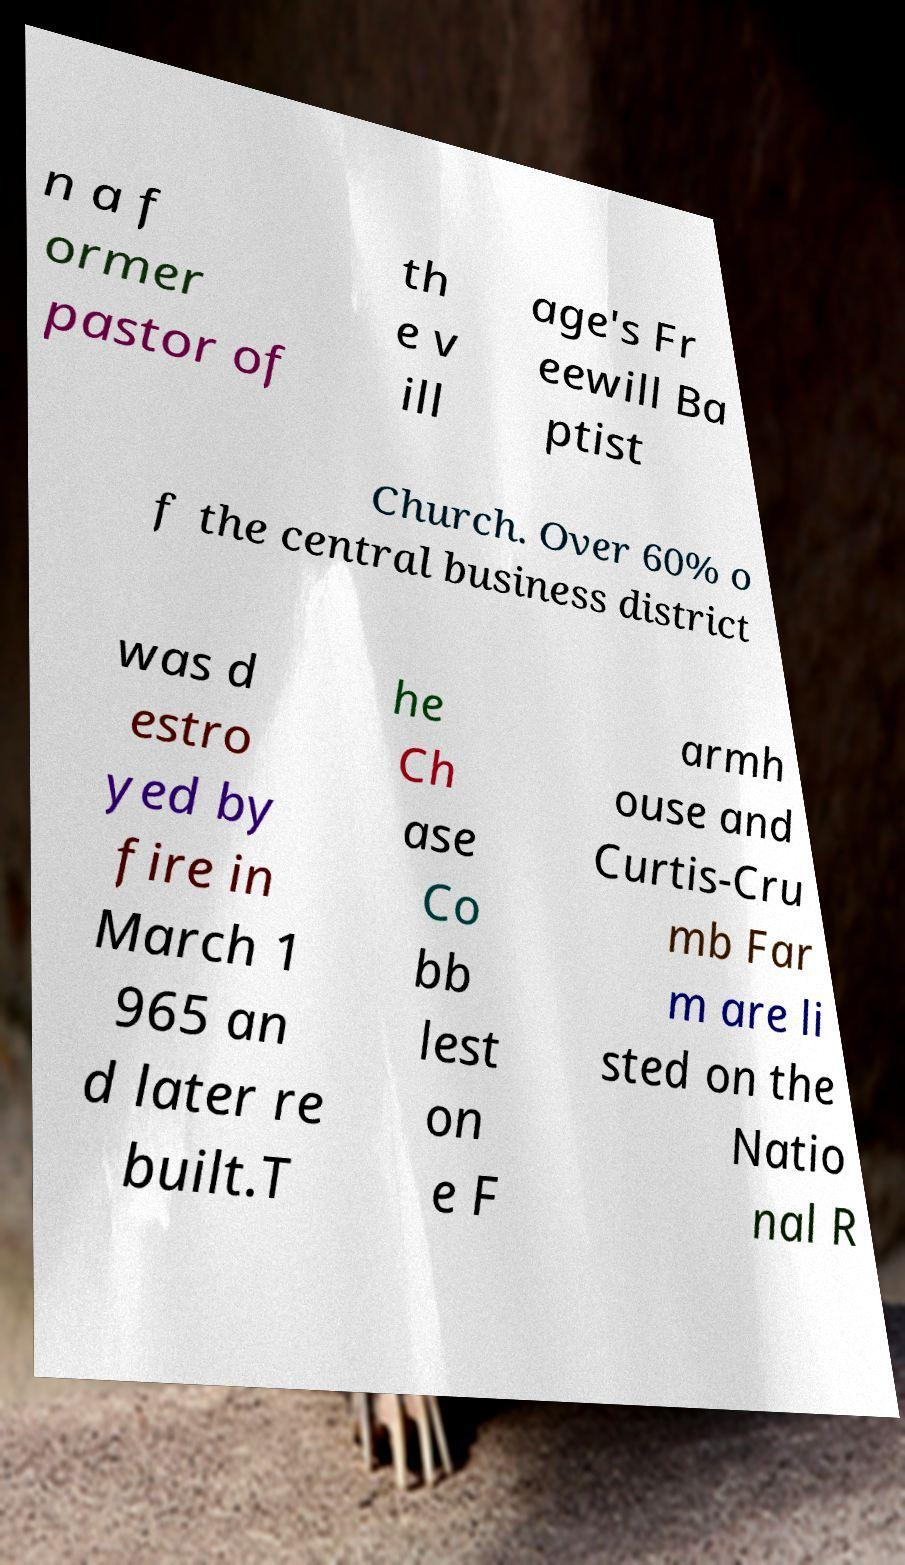What messages or text are displayed in this image? I need them in a readable, typed format. n a f ormer pastor of th e v ill age's Fr eewill Ba ptist Church. Over 60% o f the central business district was d estro yed by fire in March 1 965 an d later re built.T he Ch ase Co bb lest on e F armh ouse and Curtis-Cru mb Far m are li sted on the Natio nal R 